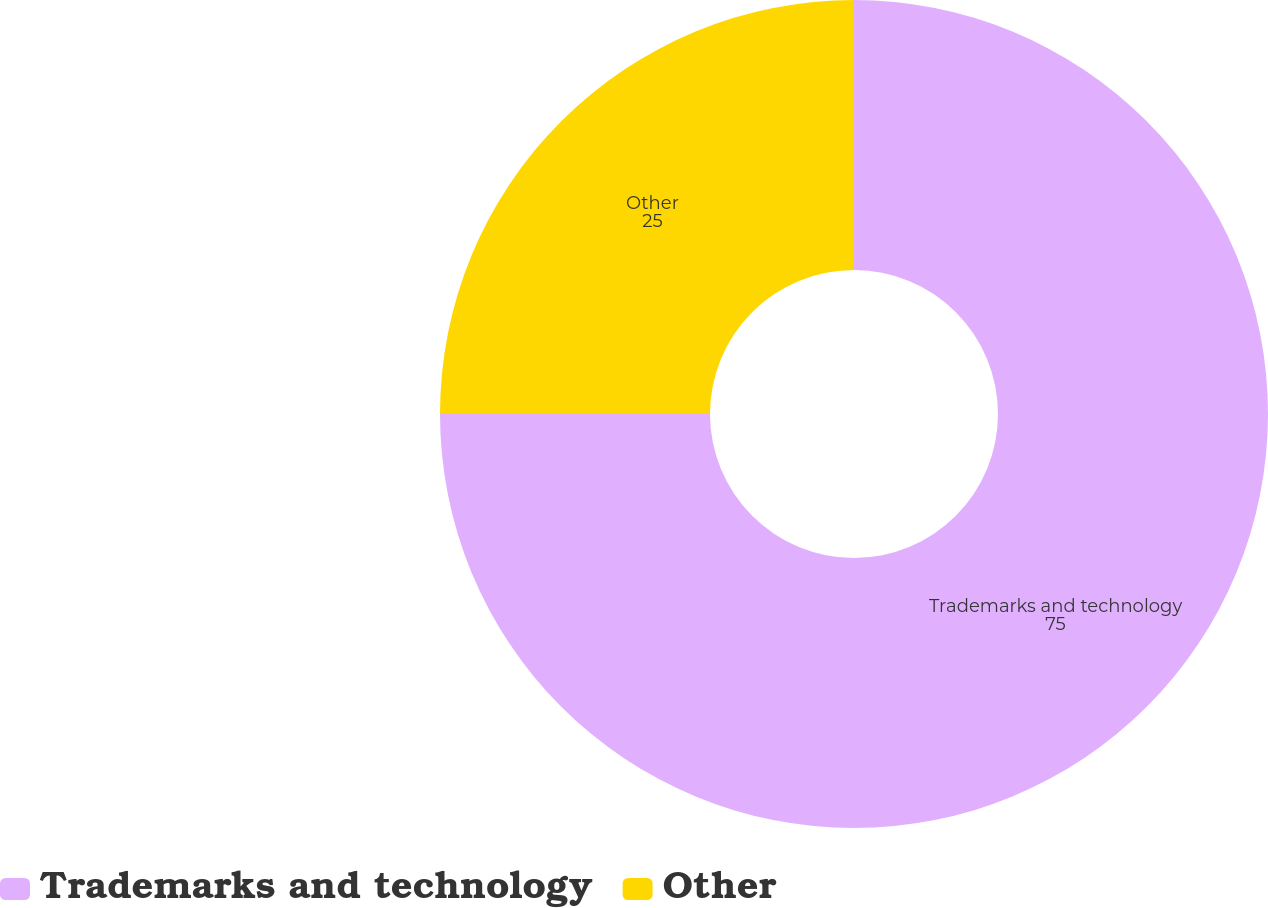Convert chart to OTSL. <chart><loc_0><loc_0><loc_500><loc_500><pie_chart><fcel>Trademarks and technology<fcel>Other<nl><fcel>75.0%<fcel>25.0%<nl></chart> 